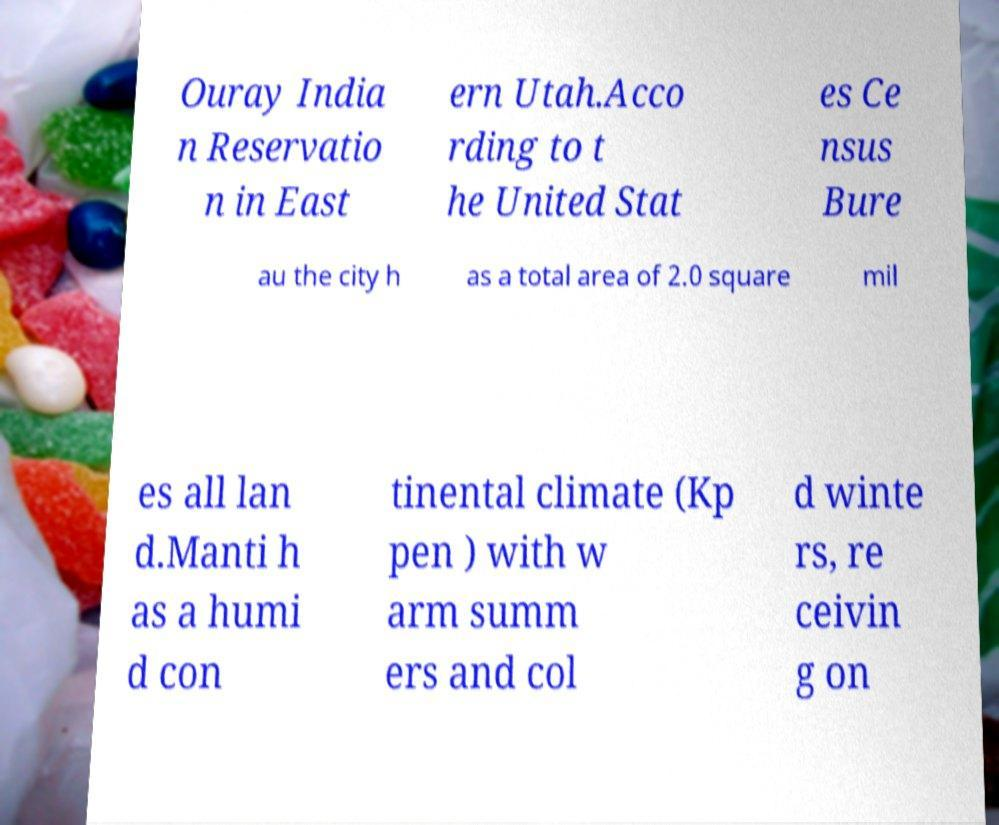Could you extract and type out the text from this image? Ouray India n Reservatio n in East ern Utah.Acco rding to t he United Stat es Ce nsus Bure au the city h as a total area of 2.0 square mil es all lan d.Manti h as a humi d con tinental climate (Kp pen ) with w arm summ ers and col d winte rs, re ceivin g on 